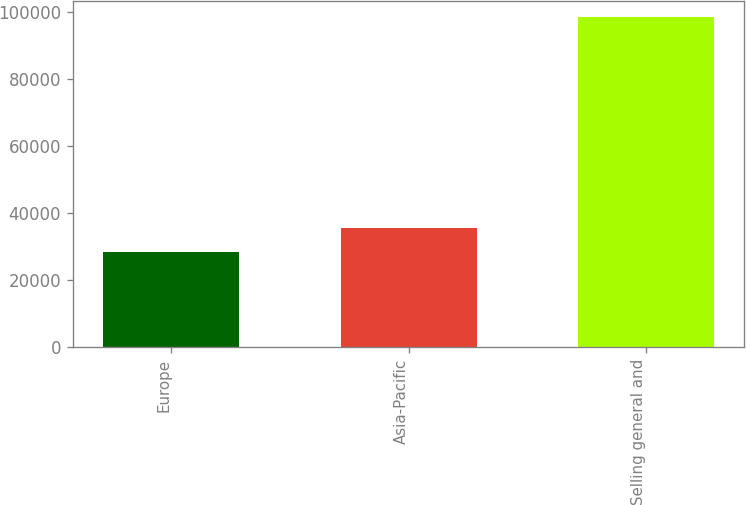Convert chart to OTSL. <chart><loc_0><loc_0><loc_500><loc_500><bar_chart><fcel>Europe<fcel>Asia-Pacific<fcel>Selling general and<nl><fcel>28503<fcel>35502.9<fcel>98502<nl></chart> 